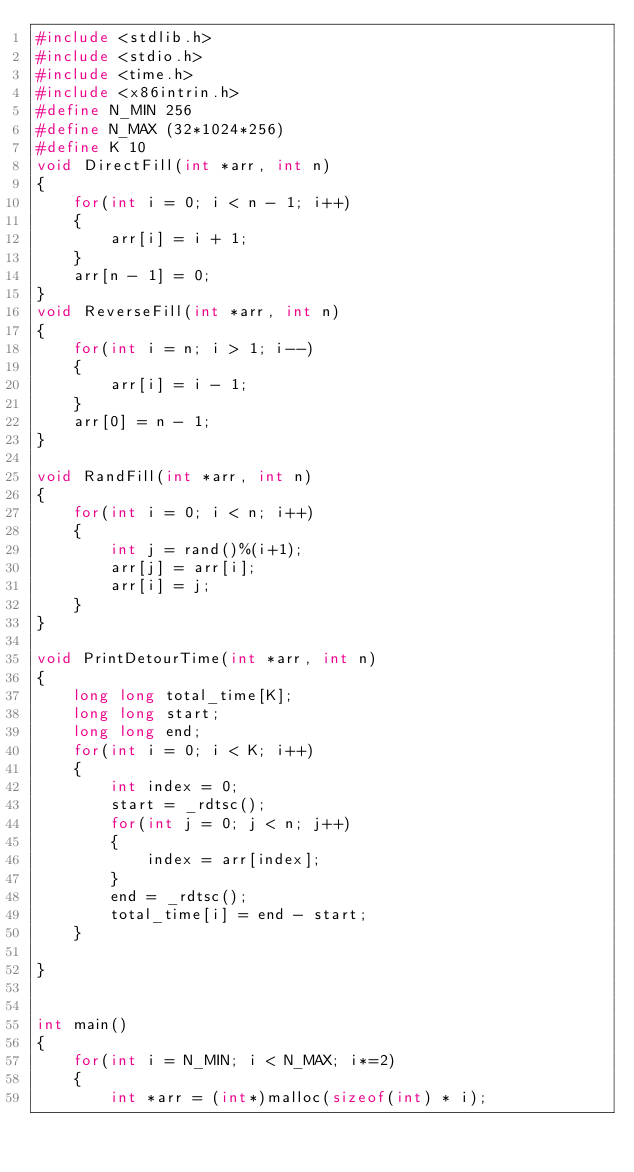Convert code to text. <code><loc_0><loc_0><loc_500><loc_500><_C_>#include <stdlib.h>
#include <stdio.h>
#include <time.h>
#include <x86intrin.h>
#define N_MIN 256
#define N_MAX (32*1024*256)
#define K 10
void DirectFill(int *arr, int n)
{
    for(int i = 0; i < n - 1; i++)
    {
        arr[i] = i + 1;
    }
    arr[n - 1] = 0;
}
void ReverseFill(int *arr, int n)
{
    for(int i = n; i > 1; i--)
    {
        arr[i] = i - 1;
    }
    arr[0] = n - 1;
}

void RandFill(int *arr, int n)
{
    for(int i = 0; i < n; i++)
    {
        int j = rand()%(i+1);
        arr[j] = arr[i];
        arr[i] = j;
    }
}

void PrintDetourTime(int *arr, int n)
{
    long long total_time[K];
    long long start;
    long long end;
    for(int i = 0; i < K; i++)
    {
        int index = 0;
        start = _rdtsc();
        for(int j = 0; j < n; j++)
        {
            index = arr[index];
        }
        end = _rdtsc();
        total_time[i] = end - start;
    }
    
}


int main()
{
    for(int i = N_MIN; i < N_MAX; i*=2)
    {
        int *arr = (int*)malloc(sizeof(int) * i);
</code> 